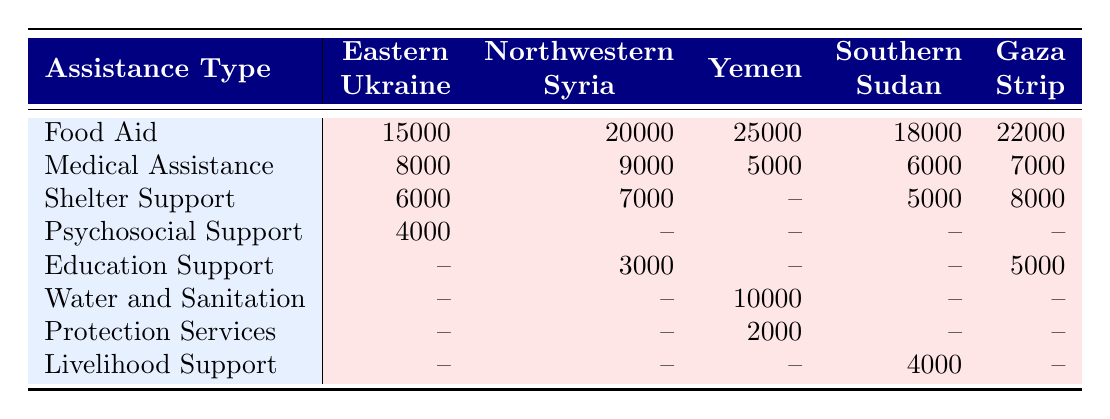What region received the highest amount of Food Aid? By looking at the values under the Food Aid row in the table, Yemen has the highest value at 25,000, compared to the other regions.
Answer: Yemen How much Medical Assistance is provided in Southern Sudan? Under the Medical Assistance row, the value for Southern Sudan is listed as 6,000.
Answer: 6,000 Which region received the least amount of Psychosocial Support? We can see that the only region that received Psychosocial Support is Eastern Ukraine with a value of 4,000 and others show no support.
Answer: Eastern Ukraine What is the combined total for Shelter Support in Gaza Strip and Yemen? The Shelter Support for Gaza Strip is 8,000 and for Yemen, it is not provided, noted as '--'. Therefore, the total is 8,000 for Gaza Strip.
Answer: 8,000 Is there any region that provides Livelihood Support? Checking the table, Southern Sudan is the only region with a value of 4,000 for Livelihood Support, confirming that support exists in this region.
Answer: Yes What is the total amount of all types of assistance provided in Northwestern Syria? Adding all the available assistance types for Northwestern Syria: Food Aid (20,000) + Medical Assistance (9,000) + Shelter Support (7,000) + Education Support (3,000) equals 39,000 in total.
Answer: 39,000 What type of assistance is not provided in Yemen? Looking at the assistance types listed for Yemen, it shows Food Aid, Water and Sanitation, Medical Assistance, and Protection Services, but not Shelter Support.
Answer: Shelter Support What is the average amount of Food Aid provided across all regions? The total Food Aid across all regions is 15,000 (Eastern Ukraine) + 20,000 (Northwestern Syria) + 25,000 (Yemen) + 18,000 (Southern Sudan) + 22,000 (Gaza Strip) = 100,000. This total is divided by 5 (the number of regions) which gives us an average of 20,000.
Answer: 20,000 How many regions provide Medical Assistance less than 7,000? Analyzing the Medical Assistance row, we see that the regions providing less than 7,000 are Yemen (5,000) and Southern Sudan (6,000), totaling 2 regions.
Answer: 2 